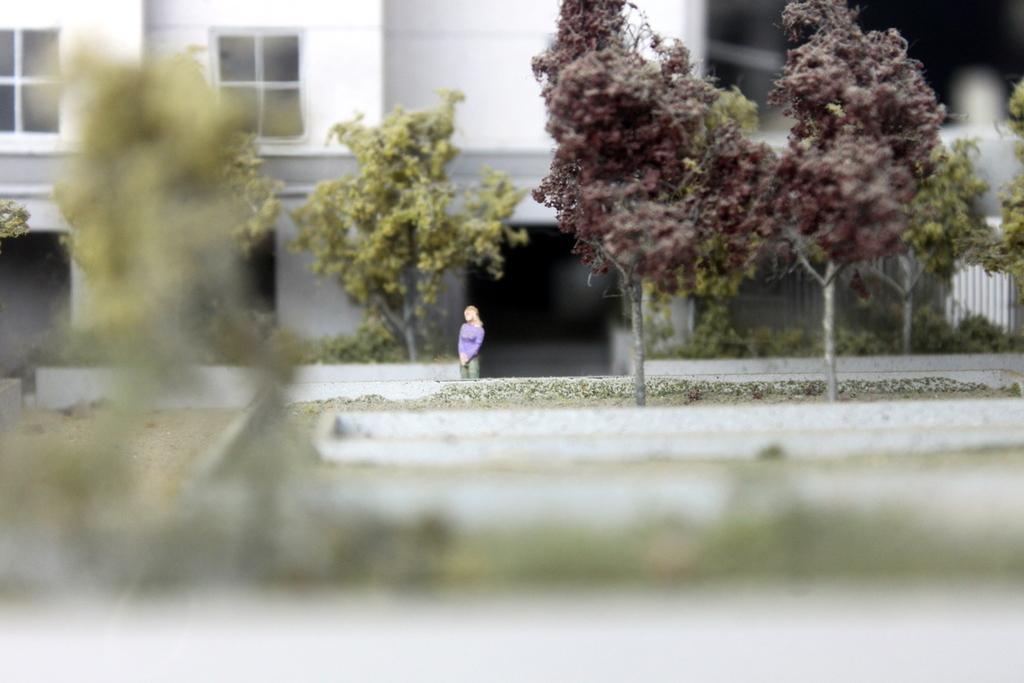Could you give a brief overview of what you see in this image? In this picture there is a woman wearing purple color t-shirt standing. Behind there is a white color building with glass window. In the front bottom side there is a blur image. 